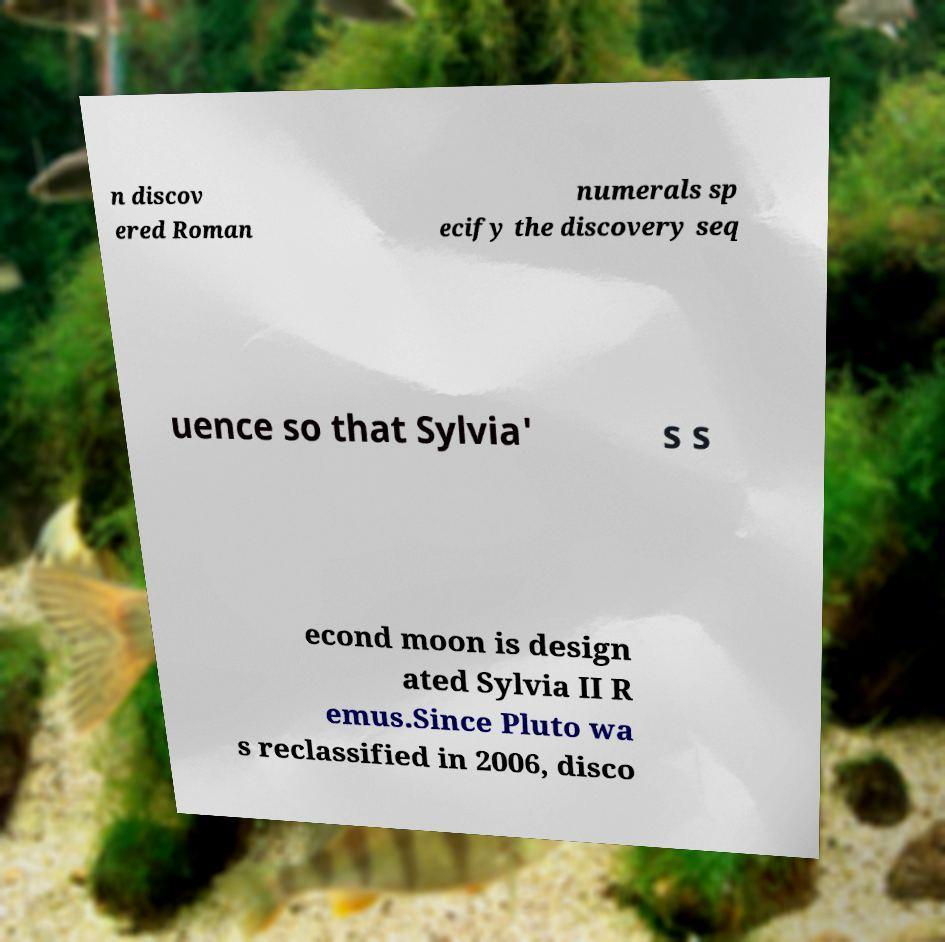Can you read and provide the text displayed in the image?This photo seems to have some interesting text. Can you extract and type it out for me? n discov ered Roman numerals sp ecify the discovery seq uence so that Sylvia' s s econd moon is design ated Sylvia II R emus.Since Pluto wa s reclassified in 2006, disco 